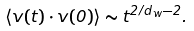<formula> <loc_0><loc_0><loc_500><loc_500>\langle { v } ( t ) \cdot { v } ( 0 ) \rangle \sim t ^ { 2 / d _ { w } - 2 } .</formula> 